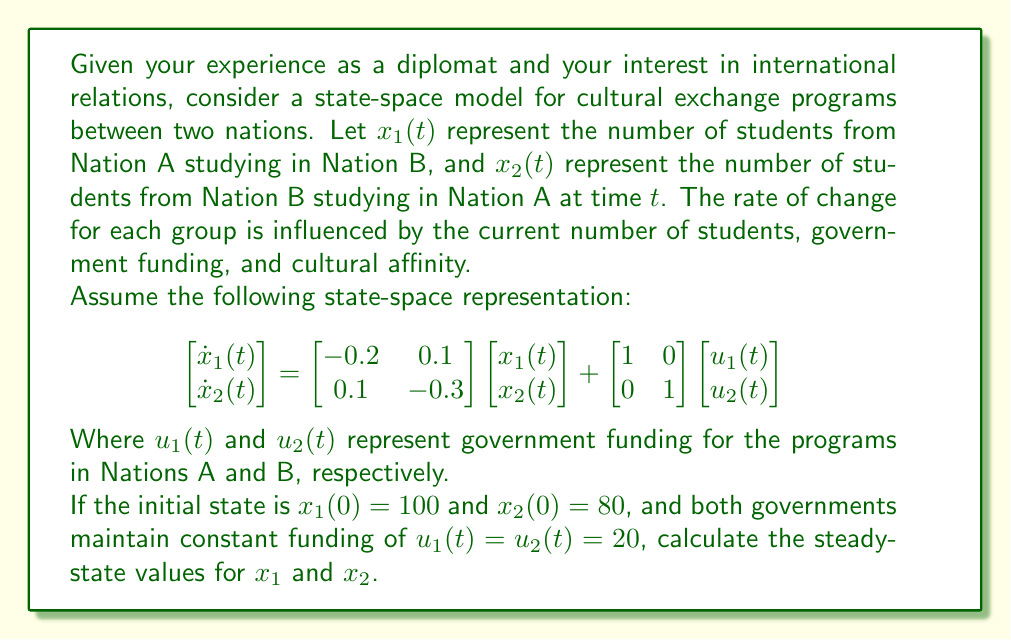Provide a solution to this math problem. To solve this problem, we'll follow these steps:

1) First, recall that in steady-state, the rate of change of the state variables is zero. So, we set $\dot{x}_1(t) = \dot{x}_2(t) = 0$.

2) Our state-space equation in steady-state becomes:

   $$\begin{bmatrix} 0 \\ 0 \end{bmatrix} = \begin{bmatrix} -0.2 & 0.1 \\ 0.1 & -0.3 \end{bmatrix} \begin{bmatrix} x_1 \\ x_2 \end{bmatrix} + \begin{bmatrix} 1 & 0 \\ 0 & 1 \end{bmatrix} \begin{bmatrix} 20 \\ 20 \end{bmatrix}$$

3) Simplify the right side:

   $$\begin{bmatrix} 0 \\ 0 \end{bmatrix} = \begin{bmatrix} -0.2x_1 + 0.1x_2 + 20 \\ 0.1x_1 - 0.3x_2 + 20 \end{bmatrix}$$

4) This gives us two equations:
   
   $-0.2x_1 + 0.1x_2 + 20 = 0$
   $0.1x_1 - 0.3x_2 + 20 = 0$

5) Multiply the first equation by 5 and the second by 10:

   $-x_1 + 0.5x_2 + 100 = 0$
   $x_1 - 3x_2 + 200 = 0$

6) Add these equations:

   $-2.5x_2 + 300 = 0$

7) Solve for $x_2$:

   $x_2 = 120$

8) Substitute this back into either of the original equations to solve for $x_1$. Let's use the first equation:

   $-0.2x_1 + 0.1(120) + 20 = 0$
   $-0.2x_1 + 32 = 0$
   $x_1 = 160$

Therefore, the steady-state values are $x_1 = 160$ and $x_2 = 120$.
Answer: The steady-state values are $x_1 = 160$ and $x_2 = 120$. 